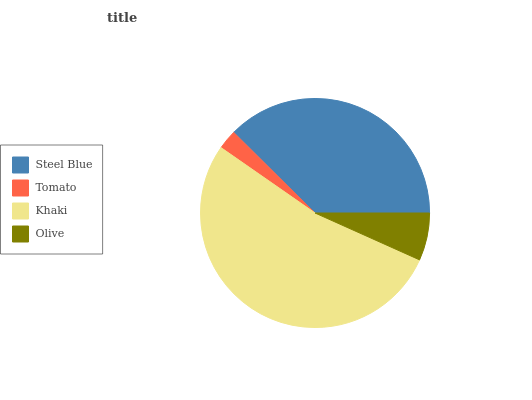Is Tomato the minimum?
Answer yes or no. Yes. Is Khaki the maximum?
Answer yes or no. Yes. Is Khaki the minimum?
Answer yes or no. No. Is Tomato the maximum?
Answer yes or no. No. Is Khaki greater than Tomato?
Answer yes or no. Yes. Is Tomato less than Khaki?
Answer yes or no. Yes. Is Tomato greater than Khaki?
Answer yes or no. No. Is Khaki less than Tomato?
Answer yes or no. No. Is Steel Blue the high median?
Answer yes or no. Yes. Is Olive the low median?
Answer yes or no. Yes. Is Khaki the high median?
Answer yes or no. No. Is Steel Blue the low median?
Answer yes or no. No. 